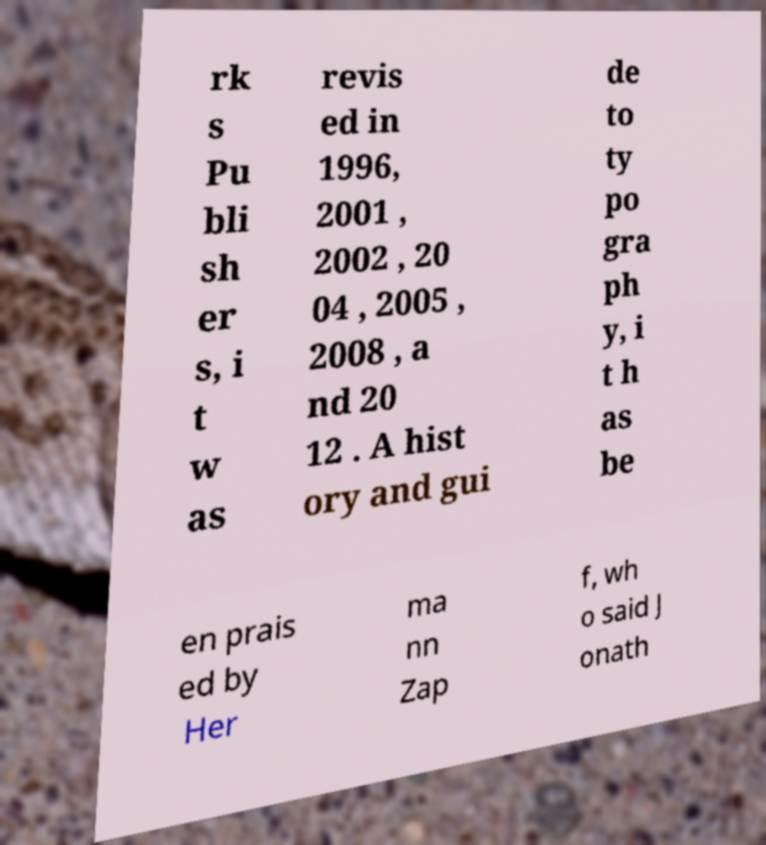There's text embedded in this image that I need extracted. Can you transcribe it verbatim? rk s Pu bli sh er s, i t w as revis ed in 1996, 2001 , 2002 , 20 04 , 2005 , 2008 , a nd 20 12 . A hist ory and gui de to ty po gra ph y, i t h as be en prais ed by Her ma nn Zap f, wh o said J onath 